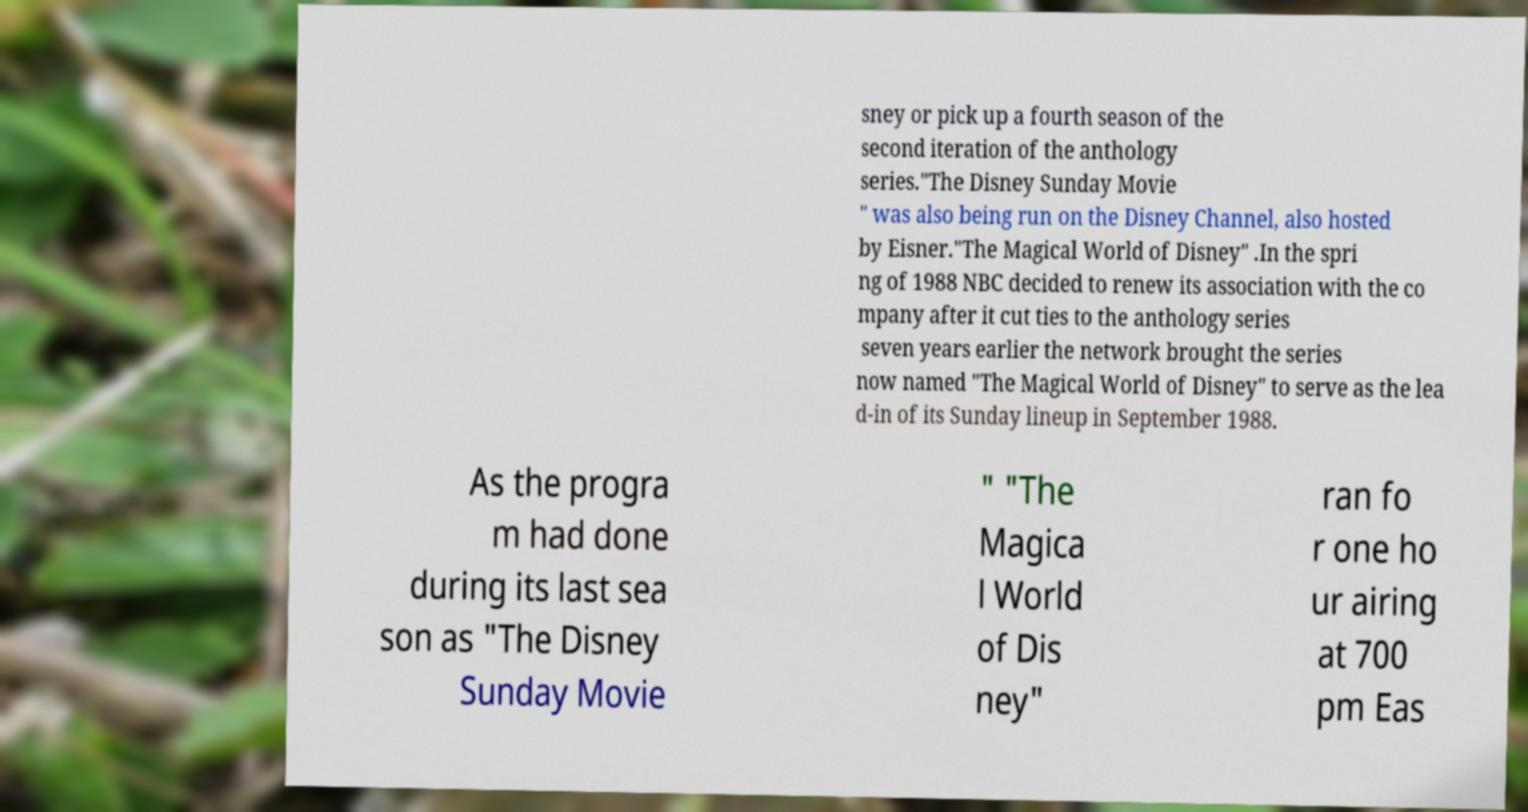For documentation purposes, I need the text within this image transcribed. Could you provide that? sney or pick up a fourth season of the second iteration of the anthology series."The Disney Sunday Movie " was also being run on the Disney Channel, also hosted by Eisner."The Magical World of Disney" .In the spri ng of 1988 NBC decided to renew its association with the co mpany after it cut ties to the anthology series seven years earlier the network brought the series now named "The Magical World of Disney" to serve as the lea d-in of its Sunday lineup in September 1988. As the progra m had done during its last sea son as "The Disney Sunday Movie " "The Magica l World of Dis ney" ran fo r one ho ur airing at 700 pm Eas 